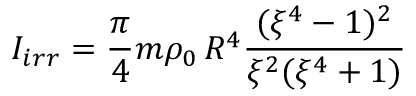<formula> <loc_0><loc_0><loc_500><loc_500>I _ { i r r } = \frac { \pi } { 4 } m \rho _ { 0 } \, R ^ { 4 } \frac { ( \xi ^ { 4 } - 1 ) ^ { 2 } } { \xi ^ { 2 } ( \xi ^ { 4 } + 1 ) }</formula> 